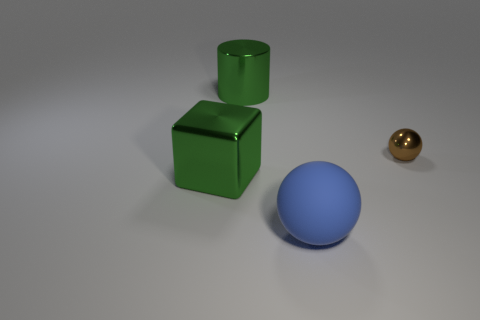How many cyan things are either big metallic blocks or shiny things?
Your answer should be compact. 0. What size is the brown ball that is made of the same material as the big green cube?
Provide a succinct answer. Small. Do the cylinder that is behind the brown sphere and the ball behind the large green block have the same material?
Keep it short and to the point. Yes. What number of balls are big green objects or red metallic objects?
Make the answer very short. 0. How many big objects are in front of the green shiny thing that is behind the large metallic object in front of the green metal cylinder?
Give a very brief answer. 2. What material is the other object that is the same shape as the big blue matte thing?
Your answer should be very brief. Metal. Are there any other things that are made of the same material as the blue thing?
Provide a succinct answer. No. What is the color of the sphere behind the big rubber object?
Offer a terse response. Brown. Is the material of the tiny thing the same as the large green thing that is in front of the brown metallic object?
Provide a succinct answer. Yes. What is the material of the big green cube?
Provide a succinct answer. Metal. 